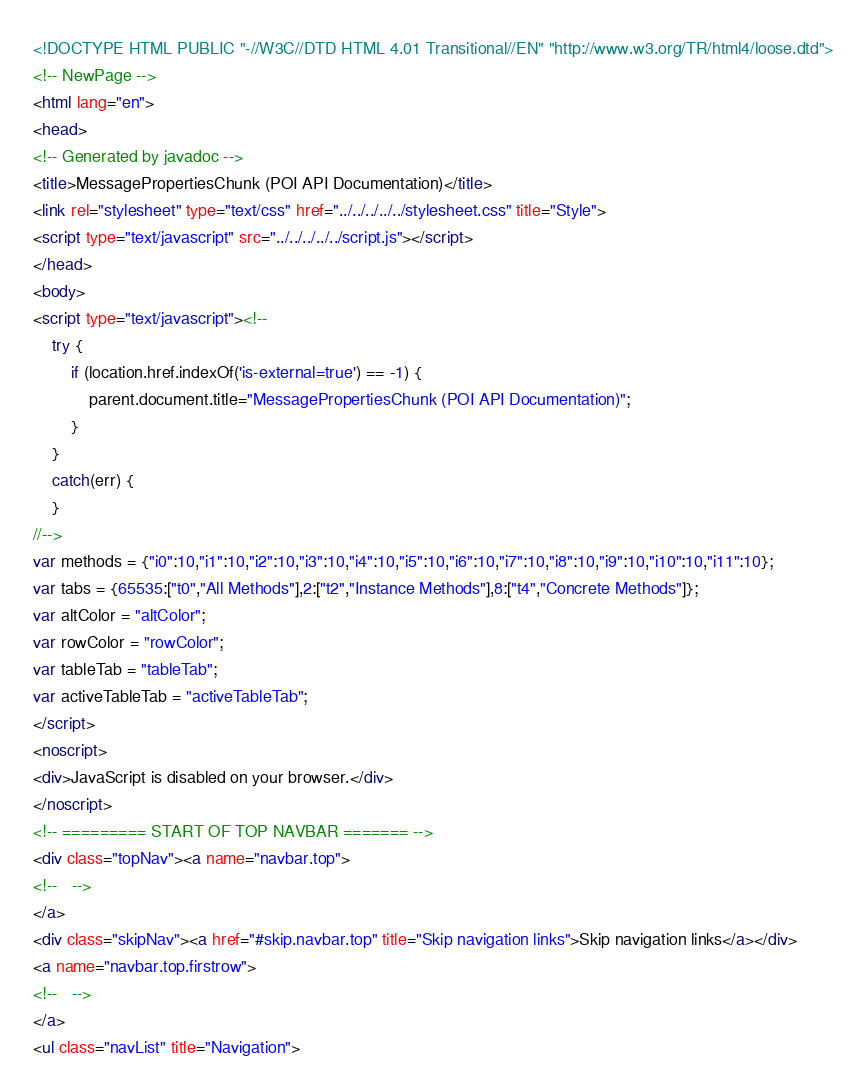Convert code to text. <code><loc_0><loc_0><loc_500><loc_500><_HTML_><!DOCTYPE HTML PUBLIC "-//W3C//DTD HTML 4.01 Transitional//EN" "http://www.w3.org/TR/html4/loose.dtd">
<!-- NewPage -->
<html lang="en">
<head>
<!-- Generated by javadoc -->
<title>MessagePropertiesChunk (POI API Documentation)</title>
<link rel="stylesheet" type="text/css" href="../../../../../stylesheet.css" title="Style">
<script type="text/javascript" src="../../../../../script.js"></script>
</head>
<body>
<script type="text/javascript"><!--
    try {
        if (location.href.indexOf('is-external=true') == -1) {
            parent.document.title="MessagePropertiesChunk (POI API Documentation)";
        }
    }
    catch(err) {
    }
//-->
var methods = {"i0":10,"i1":10,"i2":10,"i3":10,"i4":10,"i5":10,"i6":10,"i7":10,"i8":10,"i9":10,"i10":10,"i11":10};
var tabs = {65535:["t0","All Methods"],2:["t2","Instance Methods"],8:["t4","Concrete Methods"]};
var altColor = "altColor";
var rowColor = "rowColor";
var tableTab = "tableTab";
var activeTableTab = "activeTableTab";
</script>
<noscript>
<div>JavaScript is disabled on your browser.</div>
</noscript>
<!-- ========= START OF TOP NAVBAR ======= -->
<div class="topNav"><a name="navbar.top">
<!--   -->
</a>
<div class="skipNav"><a href="#skip.navbar.top" title="Skip navigation links">Skip navigation links</a></div>
<a name="navbar.top.firstrow">
<!--   -->
</a>
<ul class="navList" title="Navigation"></code> 